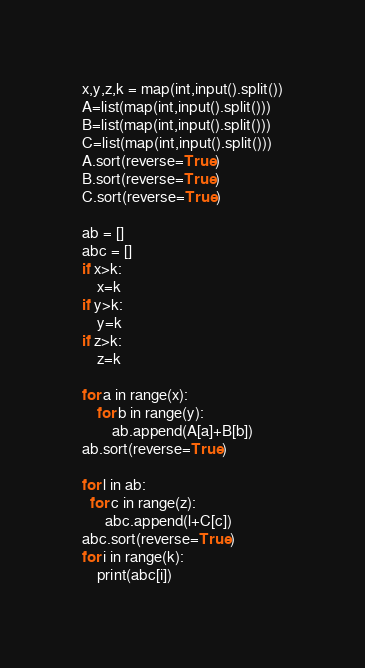<code> <loc_0><loc_0><loc_500><loc_500><_Python_>x,y,z,k = map(int,input().split())
A=list(map(int,input().split()))
B=list(map(int,input().split()))
C=list(map(int,input().split()))
A.sort(reverse=True)
B.sort(reverse=True)
C.sort(reverse=True)

ab = []
abc = []
if x>k:
    x=k
if y>k:
    y=k
if z>k:
    z=k

for a in range(x):
    for b in range(y):
        ab.append(A[a]+B[b])
ab.sort(reverse=True)

for l in ab:
  for c in range(z):
      abc.append(l+C[c])
abc.sort(reverse=True)
for i in range(k):
    print(abc[i])</code> 